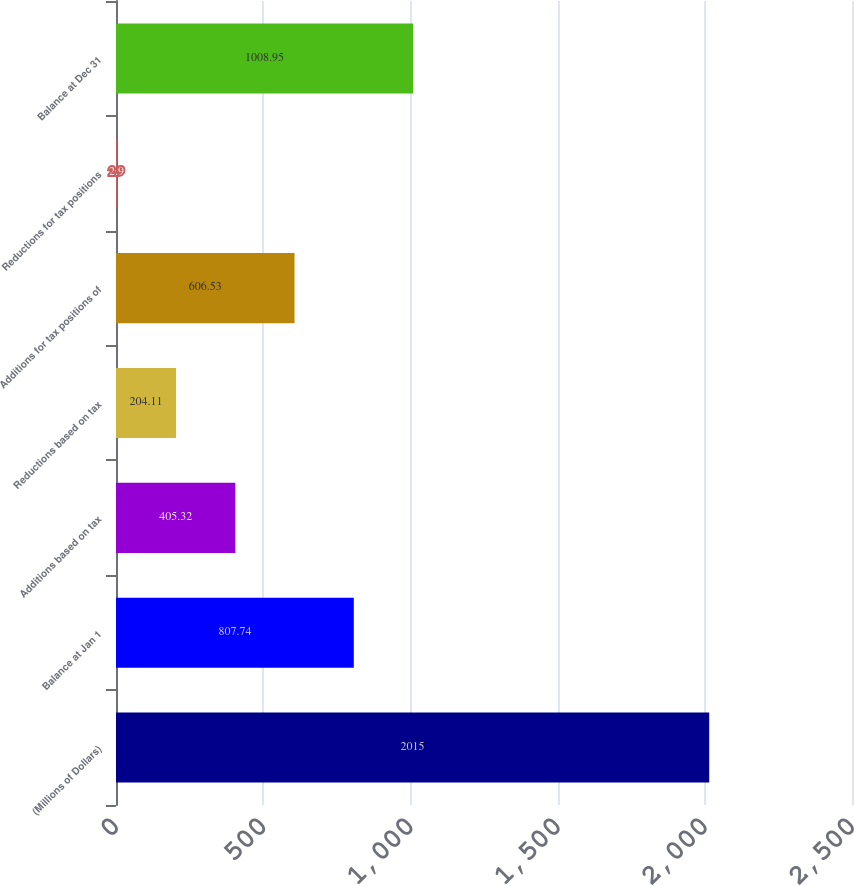<chart> <loc_0><loc_0><loc_500><loc_500><bar_chart><fcel>(Millions of Dollars)<fcel>Balance at Jan 1<fcel>Additions based on tax<fcel>Reductions based on tax<fcel>Additions for tax positions of<fcel>Reductions for tax positions<fcel>Balance at Dec 31<nl><fcel>2015<fcel>807.74<fcel>405.32<fcel>204.11<fcel>606.53<fcel>2.9<fcel>1008.95<nl></chart> 